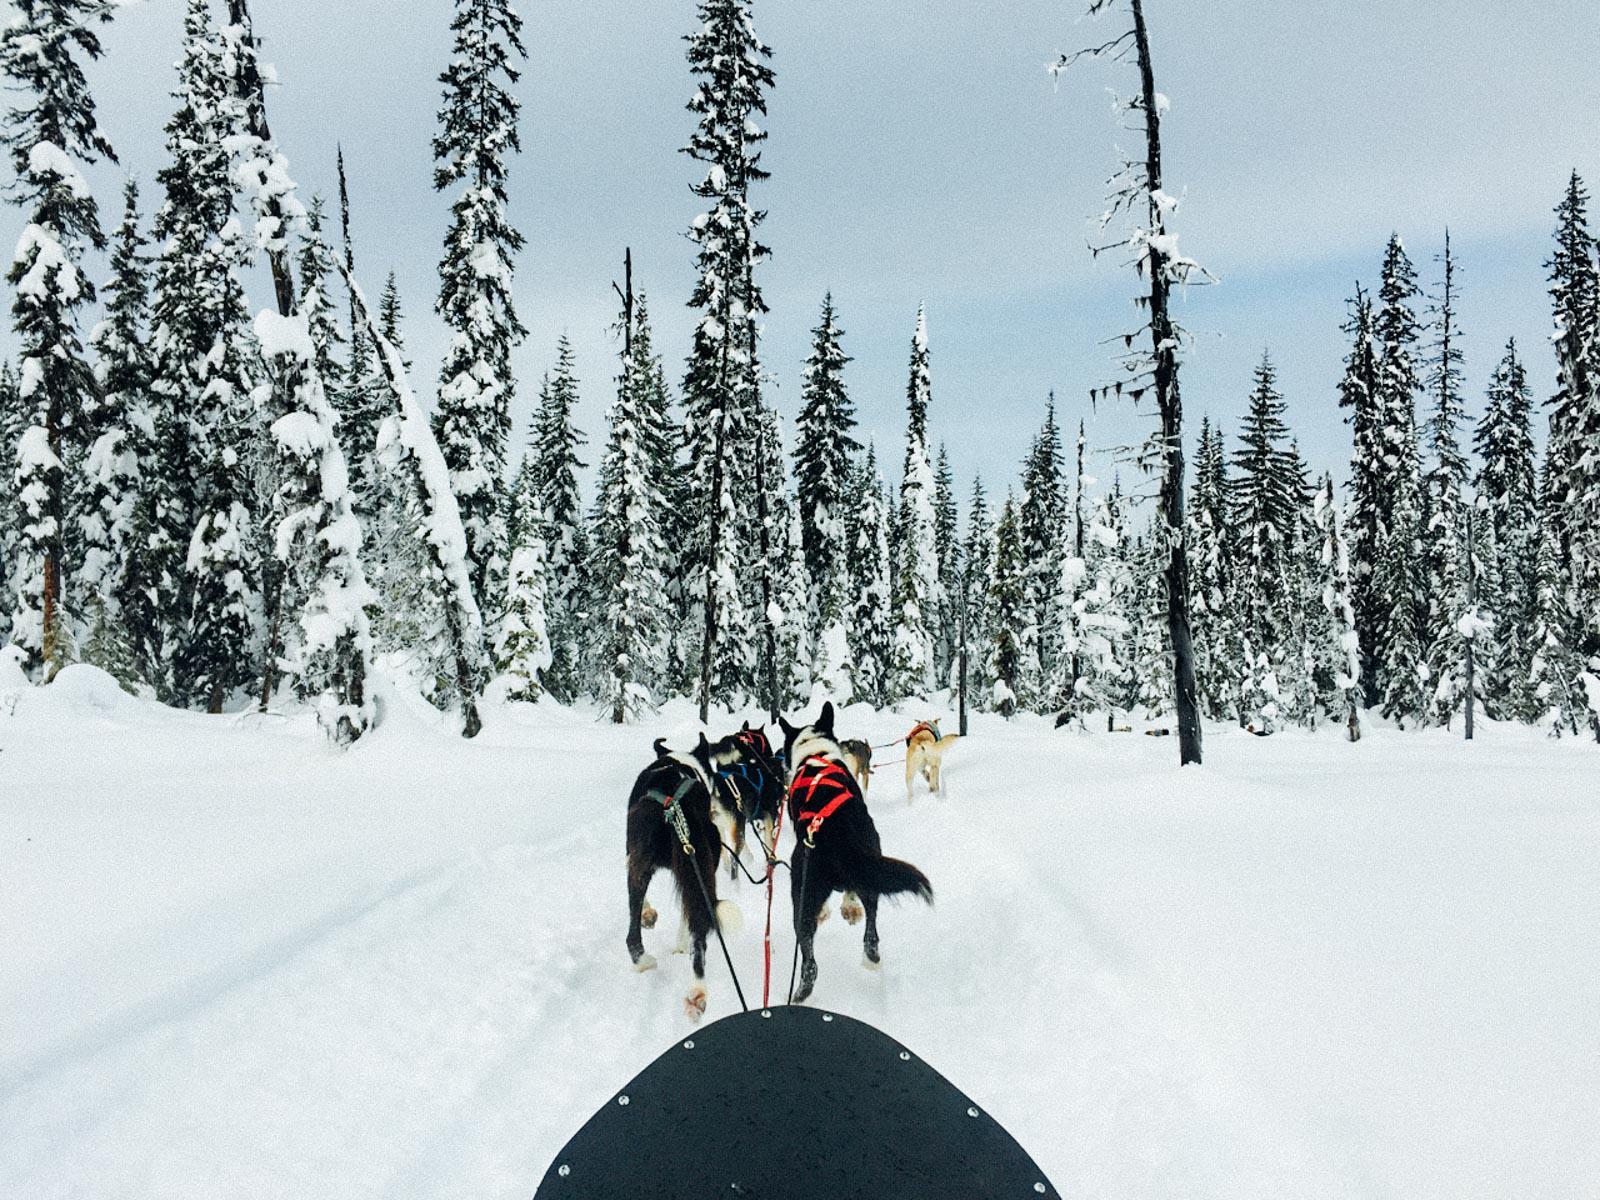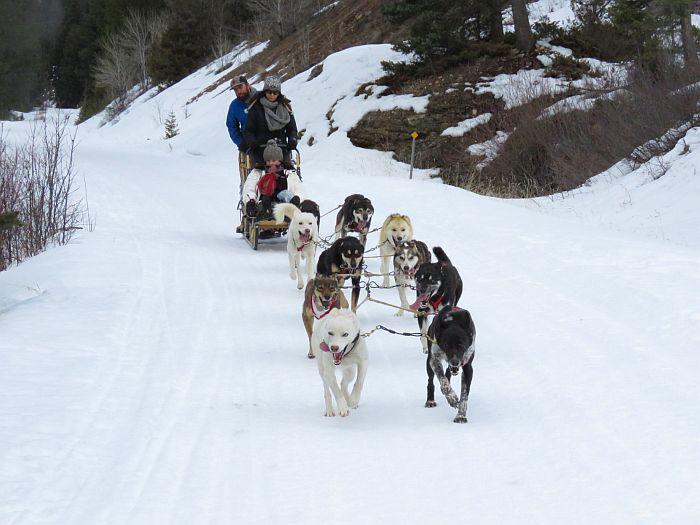The first image is the image on the left, the second image is the image on the right. Examine the images to the left and right. Is the description "At least one of the images shows a predominately black dog with white accents wearing a bright red harness on its body." accurate? Answer yes or no. Yes. The first image is the image on the left, the second image is the image on the right. Given the left and right images, does the statement "One image shows people riding the dogsled, the other does not." hold true? Answer yes or no. Yes. 